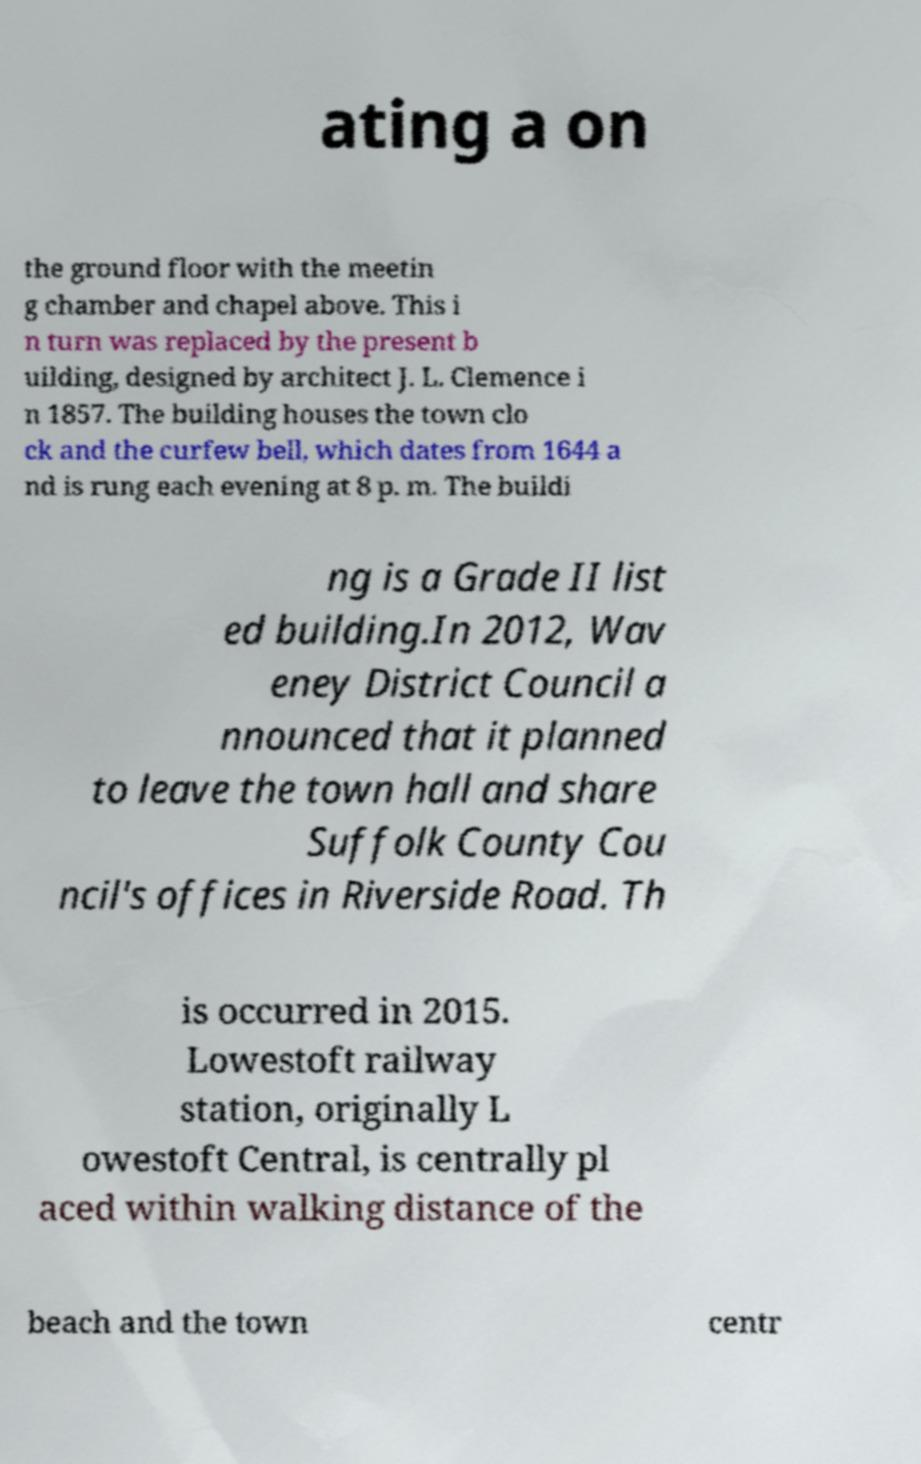What messages or text are displayed in this image? I need them in a readable, typed format. ating a on the ground floor with the meetin g chamber and chapel above. This i n turn was replaced by the present b uilding, designed by architect J. L. Clemence i n 1857. The building houses the town clo ck and the curfew bell, which dates from 1644 a nd is rung each evening at 8 p. m. The buildi ng is a Grade II list ed building.In 2012, Wav eney District Council a nnounced that it planned to leave the town hall and share Suffolk County Cou ncil's offices in Riverside Road. Th is occurred in 2015. Lowestoft railway station, originally L owestoft Central, is centrally pl aced within walking distance of the beach and the town centr 